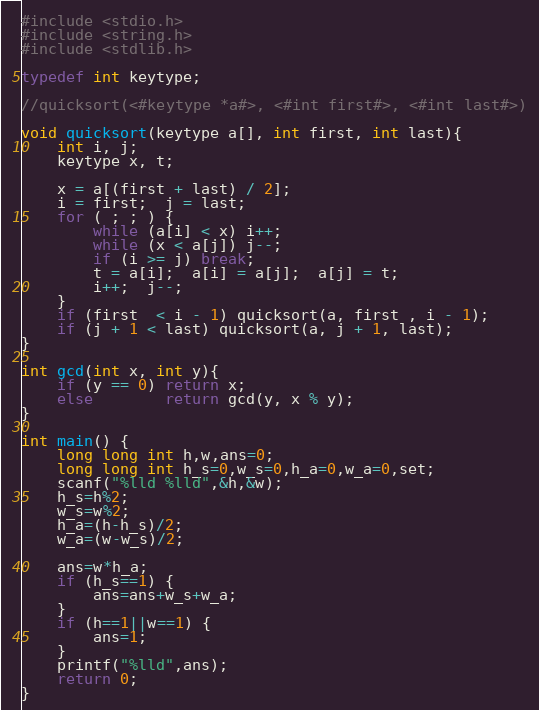<code> <loc_0><loc_0><loc_500><loc_500><_C_>#include <stdio.h>
#include <string.h>
#include <stdlib.h>

typedef int keytype;

//quicksort(<#keytype *a#>, <#int first#>, <#int last#>)

void quicksort(keytype a[], int first, int last){
    int i, j;
    keytype x, t;
    
    x = a[(first + last) / 2];
    i = first;  j = last;
    for ( ; ; ) {
        while (a[i] < x) i++;
        while (x < a[j]) j--;
        if (i >= j) break;
        t = a[i];  a[i] = a[j];  a[j] = t;
        i++;  j--;
    }
    if (first  < i - 1) quicksort(a, first , i - 1);
    if (j + 1 < last) quicksort(a, j + 1, last);
}

int gcd(int x, int y){
    if (y == 0) return x;
    else        return gcd(y, x % y);
}

int main() {
    long long int h,w,ans=0;
    long long int h_s=0,w_s=0,h_a=0,w_a=0,set;
    scanf("%lld %lld",&h,&w);
    h_s=h%2;
    w_s=w%2;
    h_a=(h-h_s)/2;
    w_a=(w-w_s)/2;
    
    ans=w*h_a;
    if (h_s==1) {
        ans=ans+w_s+w_a;
    }
    if (h==1||w==1) {
        ans=1;
    }
    printf("%lld",ans);
    return 0;
}</code> 